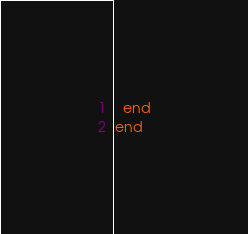<code> <loc_0><loc_0><loc_500><loc_500><_Ruby_>  end
end
</code> 